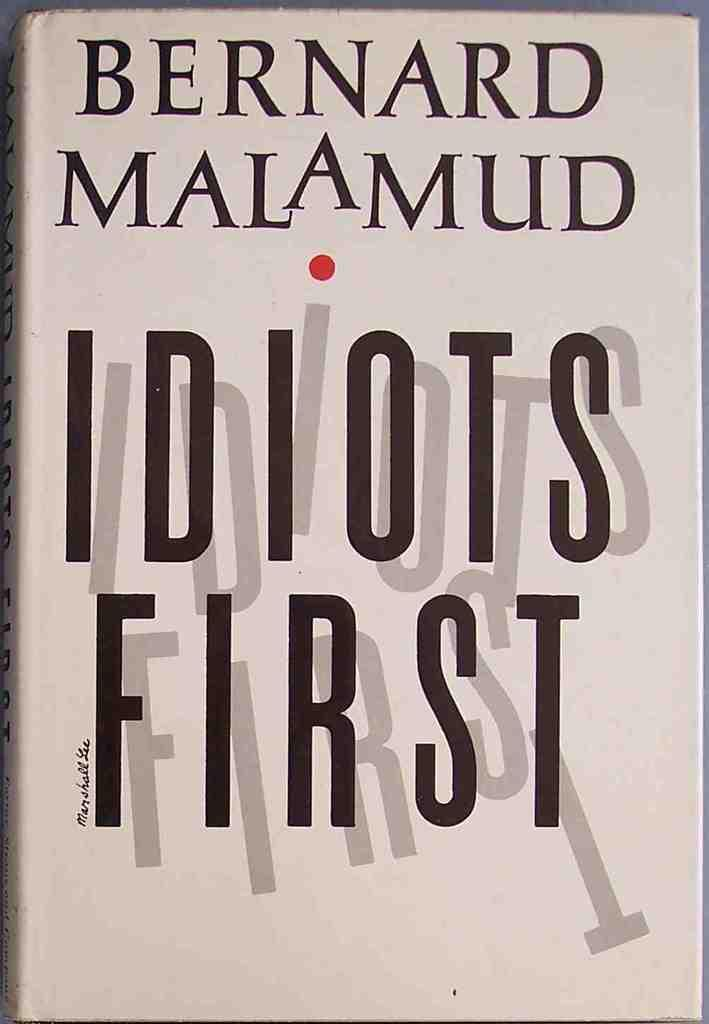<image>
Offer a succinct explanation of the picture presented. Bernard Malamud wrote this book called Idiots First. 